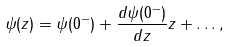Convert formula to latex. <formula><loc_0><loc_0><loc_500><loc_500>\psi ( z ) = \psi ( 0 ^ { - } ) + \frac { d \psi ( 0 ^ { - } ) } { d z } z + \dots ,</formula> 